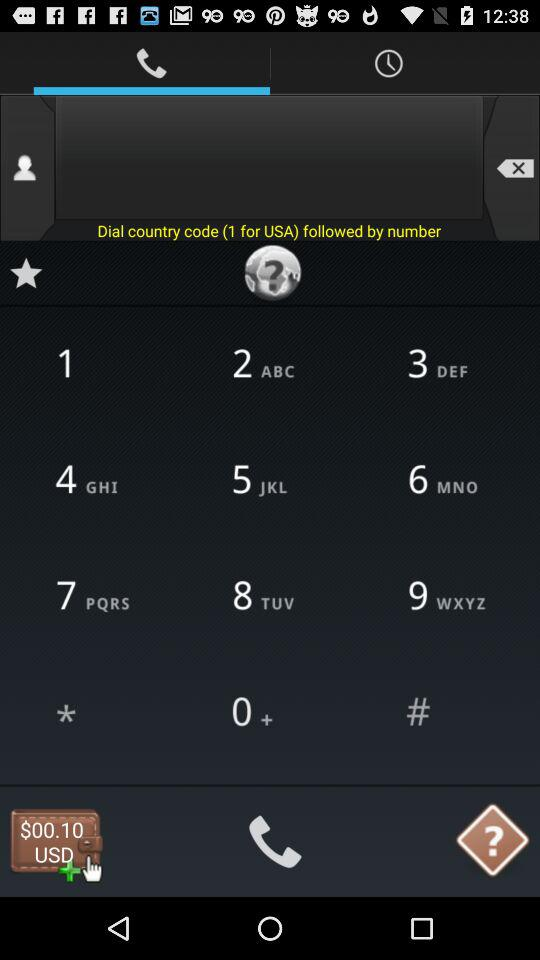What is the country code for the USA? The country code is 1. 